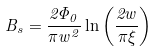Convert formula to latex. <formula><loc_0><loc_0><loc_500><loc_500>B _ { s } = \frac { 2 \Phi _ { 0 } } { \pi w ^ { 2 } } \ln \left ( \frac { 2 w } { \pi \xi } \right )</formula> 